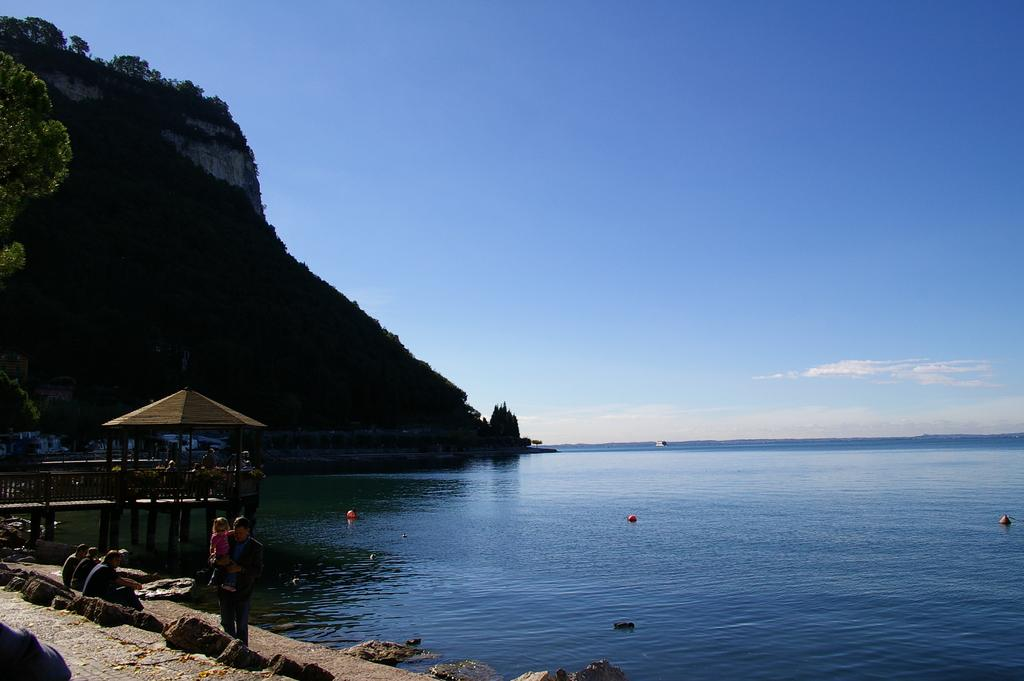What type of natural feature is on the left side of the image? There is a sea on the left side of the image. What are the people in the image doing? There are people sitting on the beach and standing in the image. What type of structure is present in the image? There is a hut in the image. What can be seen in the distance in the image? There is a mountain in the background of the image. What type of window can be seen in the image? There is no window present in the image; it features a sea, beach, people, a hut, and a mountain. How does the governor interact with the people in the image? There is no governor present in the image, so it is not possible to determine how they might interact with the people. 